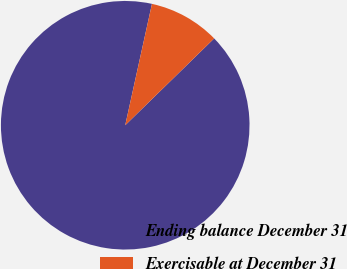Convert chart to OTSL. <chart><loc_0><loc_0><loc_500><loc_500><pie_chart><fcel>Ending balance December 31<fcel>Exercisable at December 31<nl><fcel>90.76%<fcel>9.24%<nl></chart> 